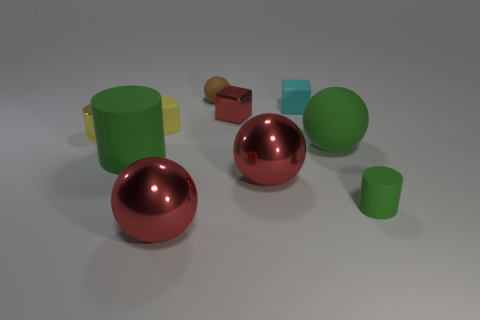There is a rubber thing that is the same color as the tiny metallic cylinder; what size is it?
Offer a very short reply. Small. How many other objects are the same shape as the small yellow matte object?
Your answer should be compact. 2. Do the brown matte object and the large green thing to the right of the small red shiny block have the same shape?
Offer a terse response. Yes. What number of spheres are in front of the large cylinder?
Your response must be concise. 2. Is the shape of the small object to the left of the large green cylinder the same as  the small green object?
Offer a very short reply. Yes. What is the color of the metal object that is behind the metallic cylinder?
Provide a succinct answer. Red. There is a small object that is made of the same material as the yellow cylinder; what is its shape?
Your answer should be compact. Cube. Is there anything else of the same color as the small matte sphere?
Your answer should be very brief. No. Is the number of matte blocks in front of the red cube greater than the number of small yellow rubber cubes in front of the yellow rubber object?
Your response must be concise. Yes. How many rubber objects have the same size as the yellow metallic cylinder?
Offer a very short reply. 4. 